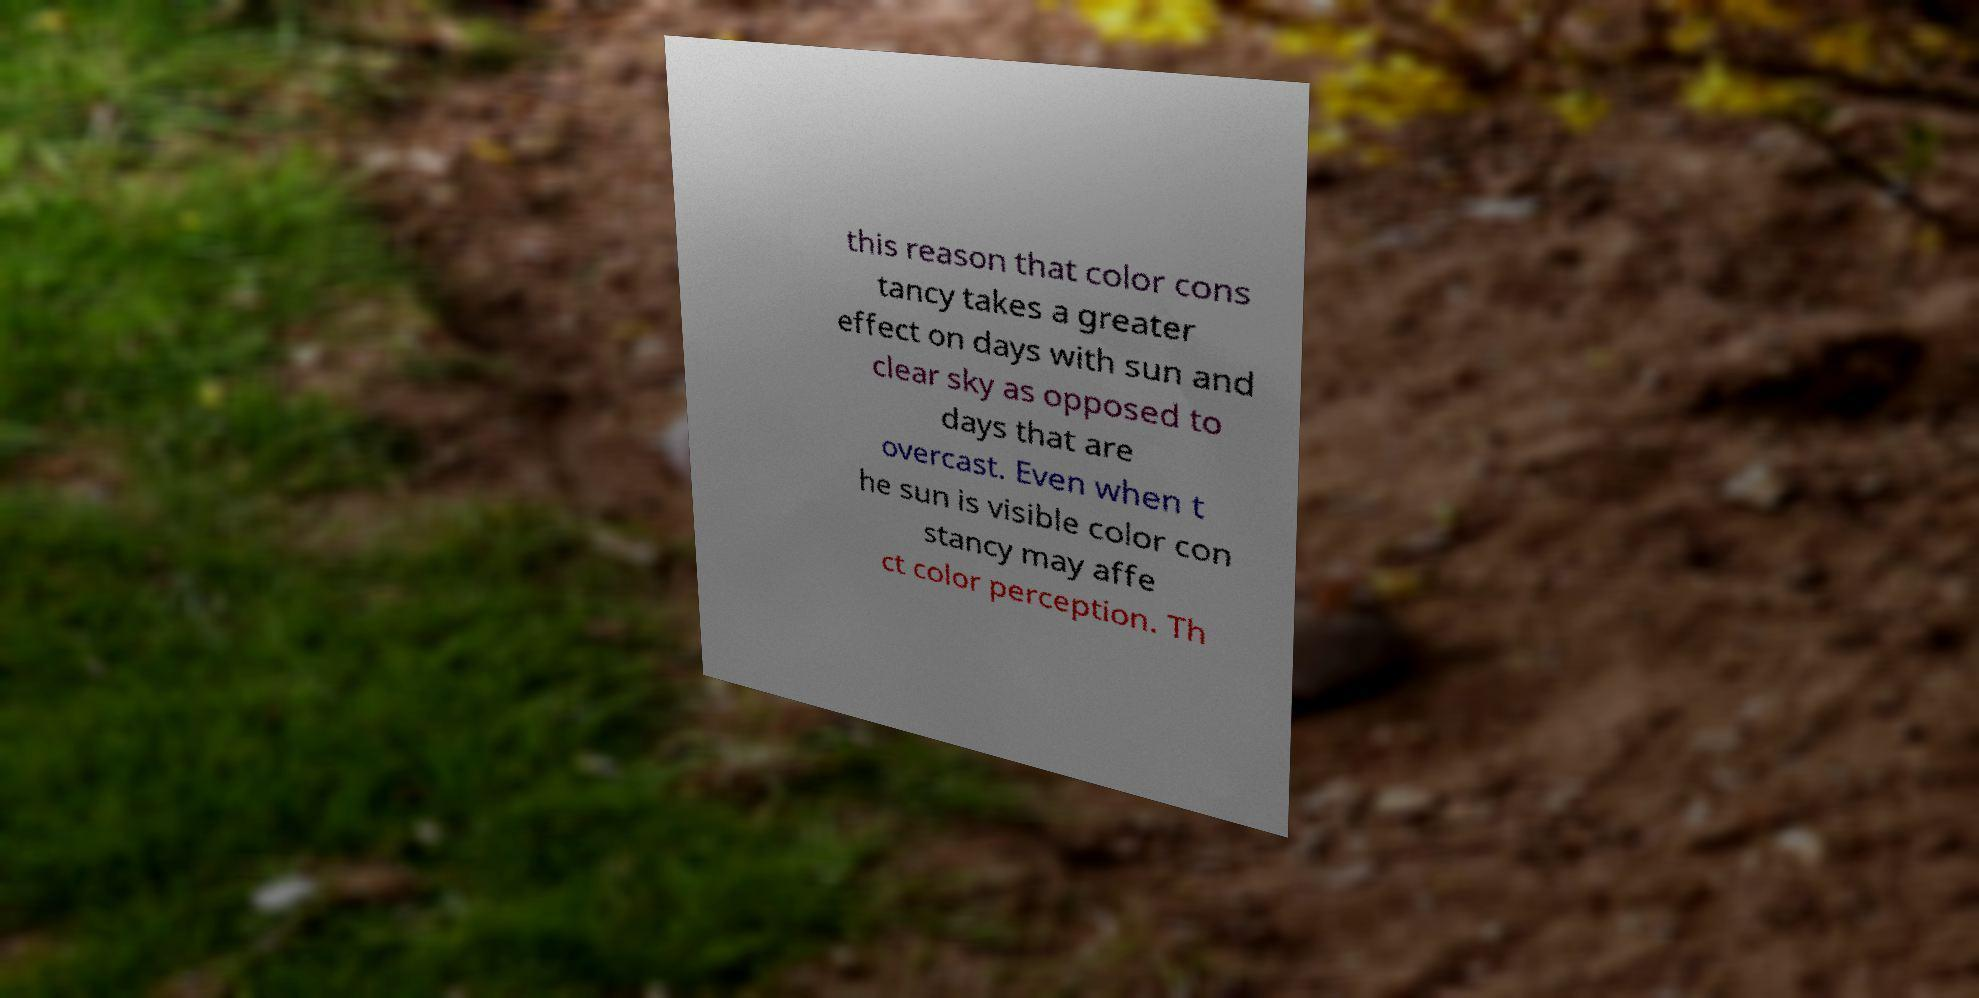Please identify and transcribe the text found in this image. this reason that color cons tancy takes a greater effect on days with sun and clear sky as opposed to days that are overcast. Even when t he sun is visible color con stancy may affe ct color perception. Th 